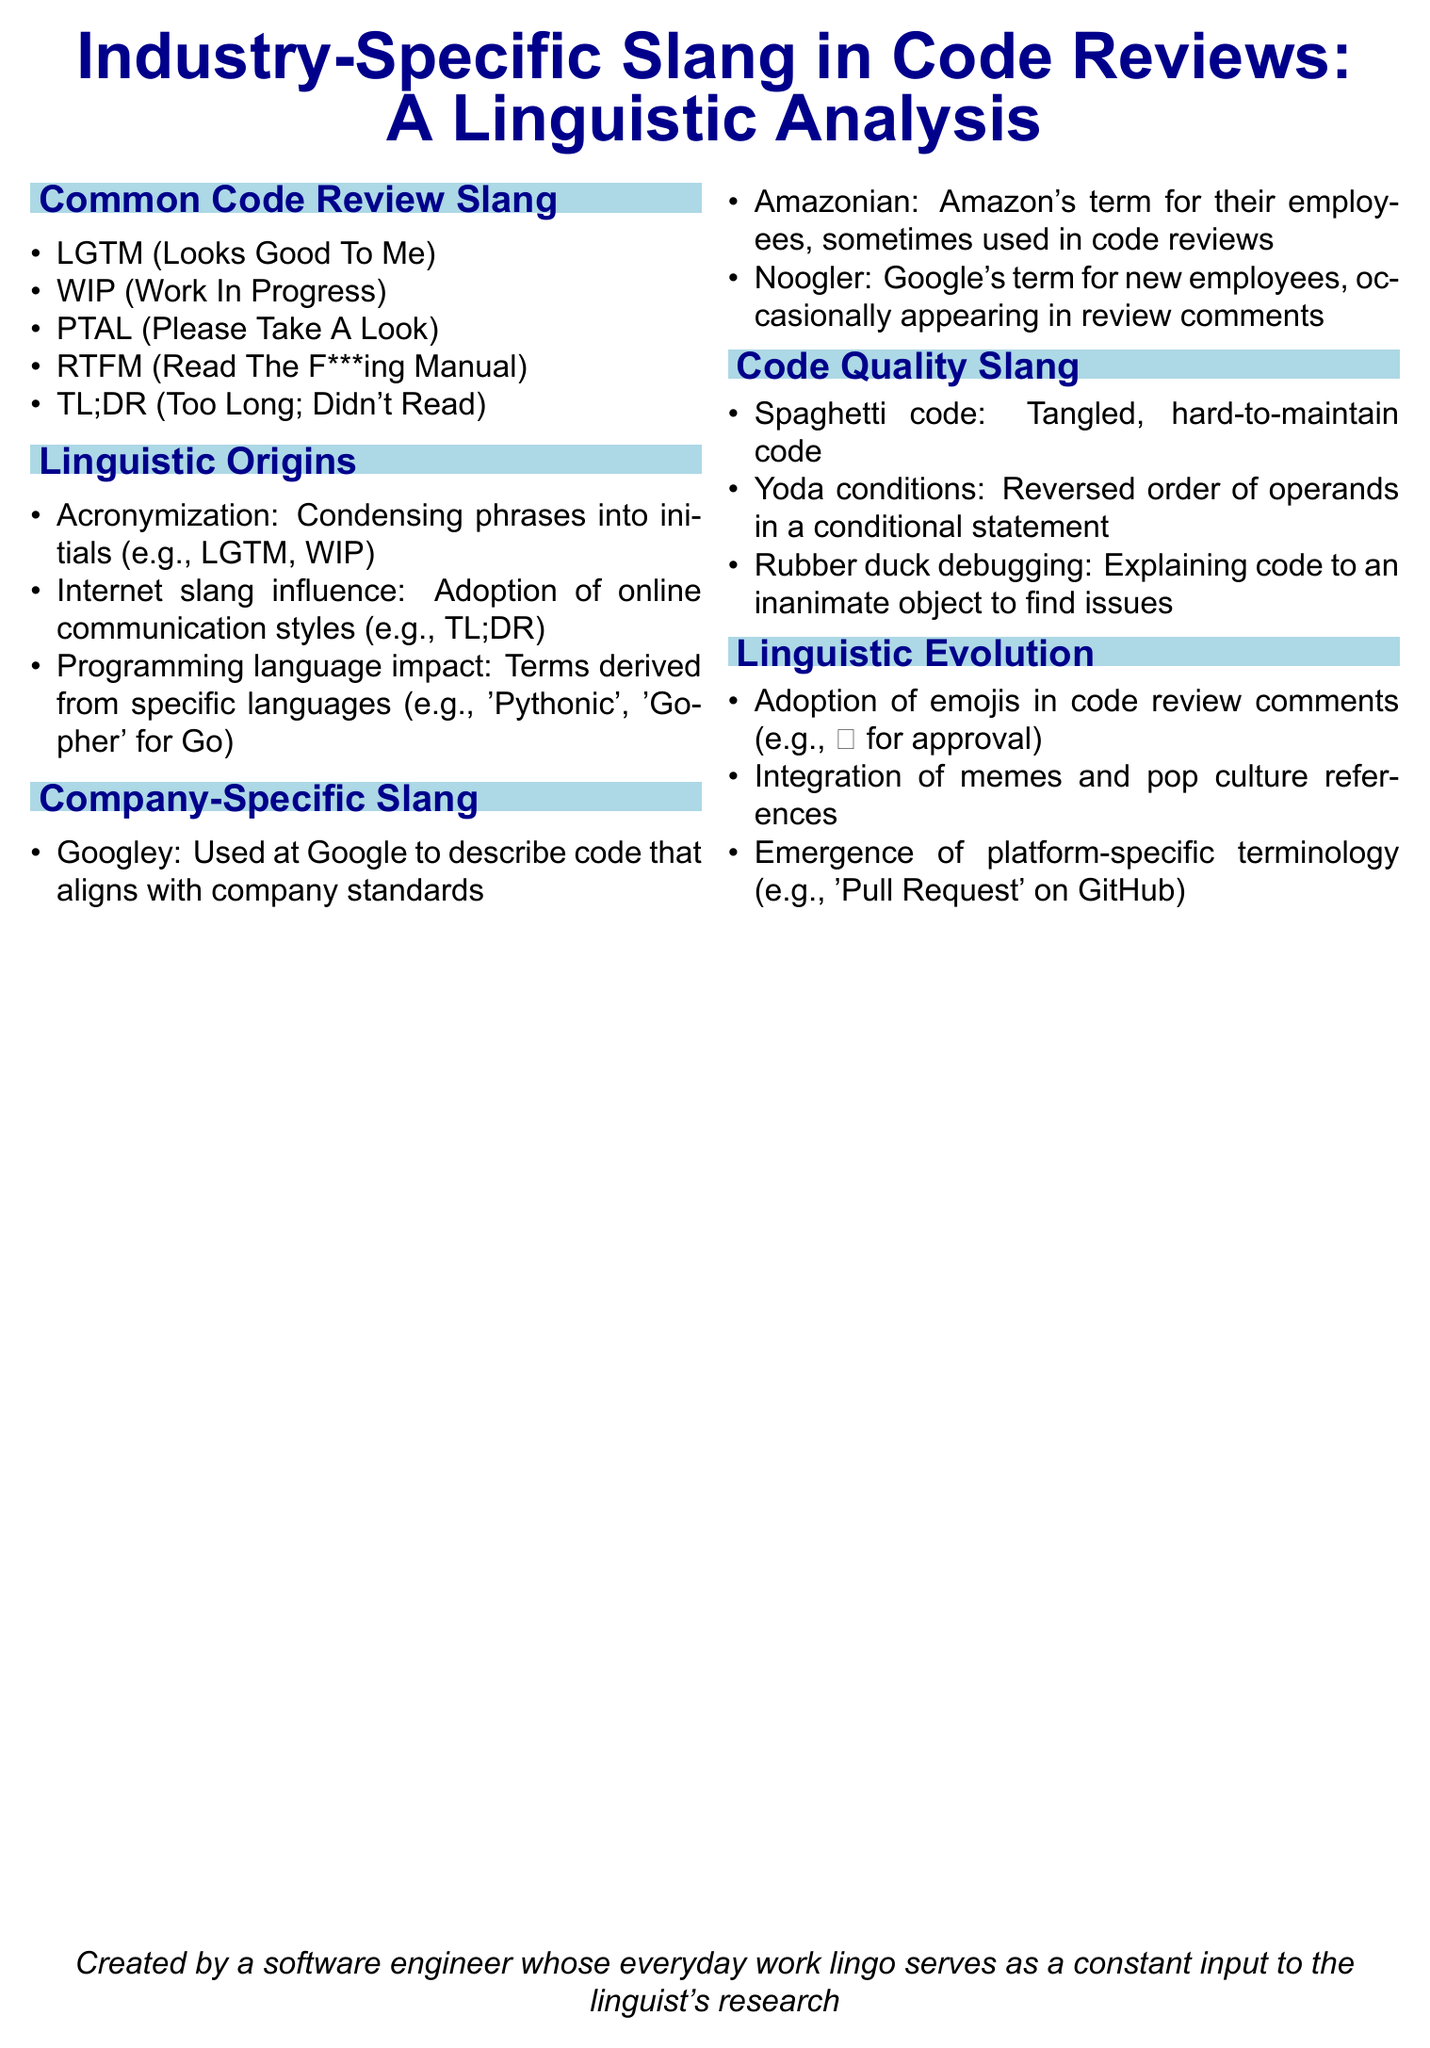What does LGTM stand for? LGTM is an acronym listed under Common Code Review Slang in the document.
Answer: Looks Good To Me What is the meaning of RTFM? RTFM is identified in the Common Code Review Slang section and elaborated in the document.
Answer: Read The F***ing Manual Which slang term describes tangled, hard-to-maintain code? This term is found under Code Quality Slang and represents a common phrase in software development.
Answer: Spaghetti code What influences the adoption of TL;DR? The origin of TL;DR is noted in the Linguistic Origins section of the document, indicating its context.
Answer: Internet slang influence What type of slang is "Googley"? This term is mentioned in the Company-Specific Slang section, providing insight into corporate culture.
Answer: Company-specific How many linguistic evolution items are listed? The document includes a specific count of items in the Linguistic Evolution section.
Answer: Three What company term is used for new employees at Google? This term is detailed in the Company-Specific Slang section and highlights a unique company culture.
Answer: Noogler What does the term "Rubber duck debugging" refer to? This phrase is explained in the Code Quality Slang segment of the document.
Answer: Explaining code to an inanimate object to find issues What kind of terminology is "Pull Request"? This phrase appears in the Linguistic Evolution section, indicating its specific context.
Answer: Platform-specific terminology 